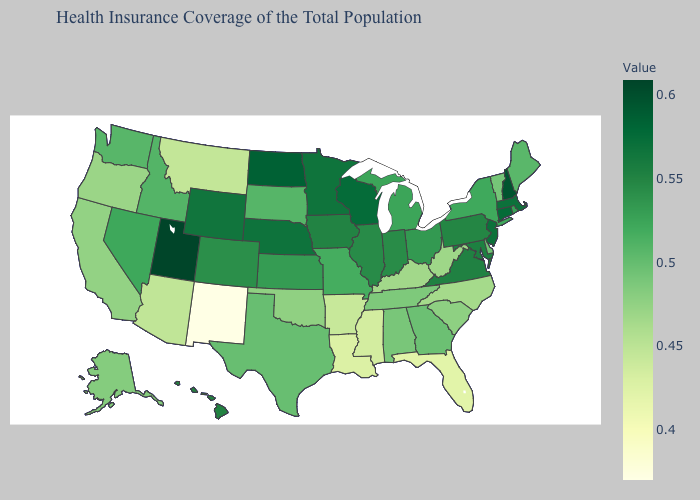Does New Mexico have the lowest value in the USA?
Answer briefly. Yes. Does New York have the lowest value in the Northeast?
Concise answer only. No. Among the states that border Oklahoma , which have the highest value?
Keep it brief. Colorado. 